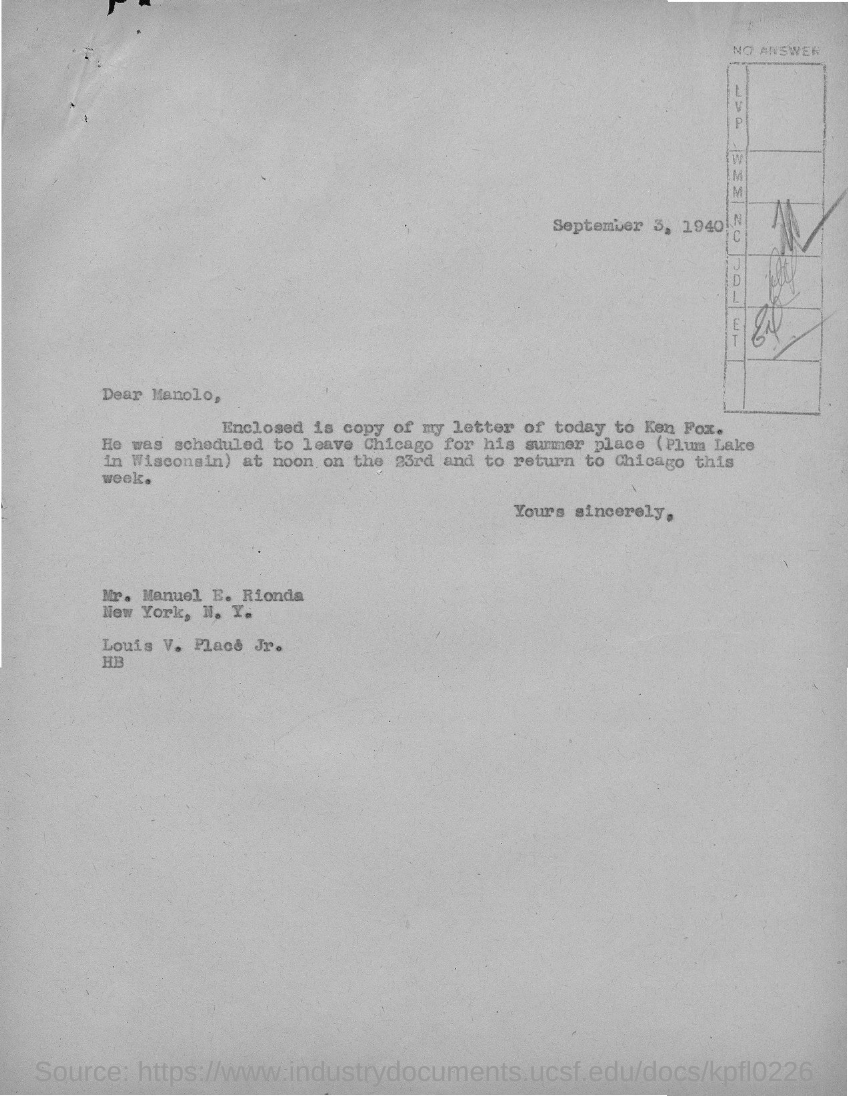What is the date mentioned in the given page ?
Your answer should be compact. September 3, 1940. To whom the letter was sent ?
Make the answer very short. Mr. Manuel E. Rionda. 